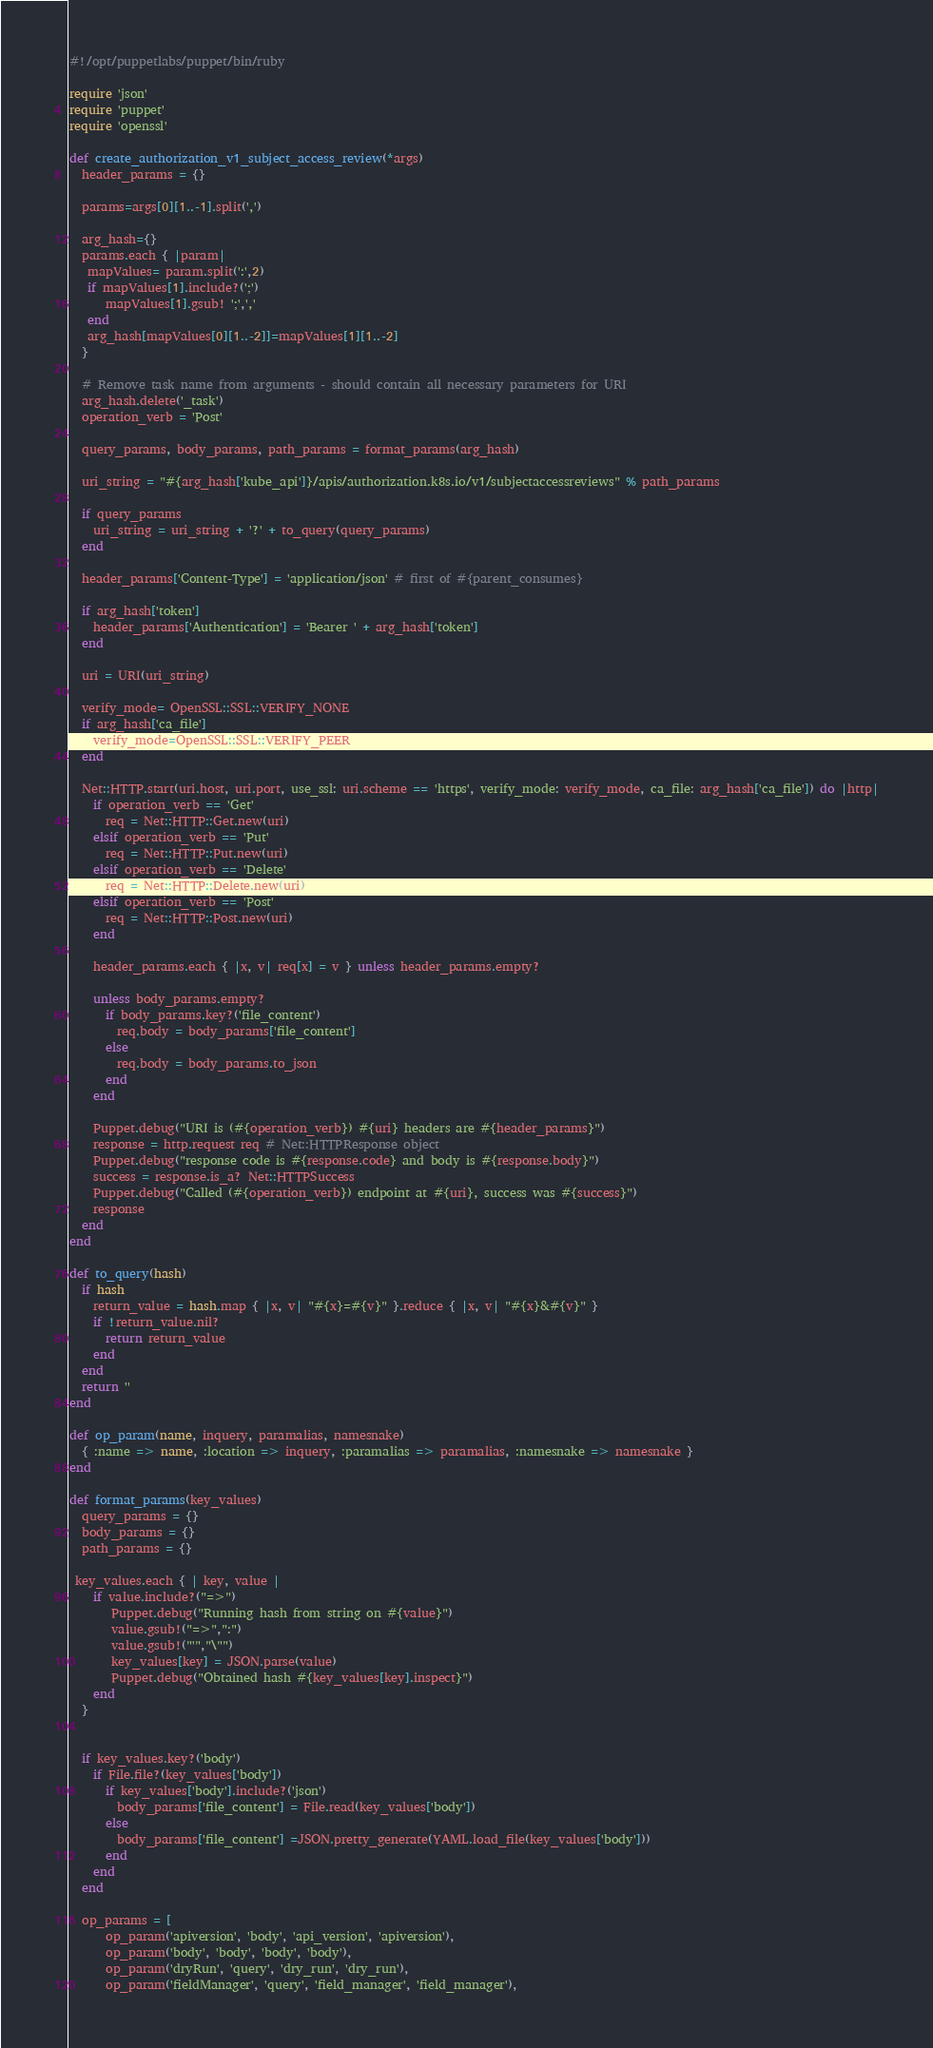Convert code to text. <code><loc_0><loc_0><loc_500><loc_500><_Ruby_>#!/opt/puppetlabs/puppet/bin/ruby

require 'json'
require 'puppet'
require 'openssl'

def create_authorization_v1_subject_access_review(*args)
  header_params = {}
  
  params=args[0][1..-1].split(',')

  arg_hash={}
  params.each { |param|
   mapValues= param.split(':',2)
   if mapValues[1].include?(';')
      mapValues[1].gsub! ';',','
   end
   arg_hash[mapValues[0][1..-2]]=mapValues[1][1..-2]
  }

  # Remove task name from arguments - should contain all necessary parameters for URI
  arg_hash.delete('_task')
  operation_verb = 'Post'

  query_params, body_params, path_params = format_params(arg_hash)

  uri_string = "#{arg_hash['kube_api']}/apis/authorization.k8s.io/v1/subjectaccessreviews" % path_params

  if query_params
    uri_string = uri_string + '?' + to_query(query_params)
  end

  header_params['Content-Type'] = 'application/json' # first of #{parent_consumes}

  if arg_hash['token']
    header_params['Authentication'] = 'Bearer ' + arg_hash['token']
  end

  uri = URI(uri_string)
 
  verify_mode= OpenSSL::SSL::VERIFY_NONE
  if arg_hash['ca_file']
    verify_mode=OpenSSL::SSL::VERIFY_PEER
  end

  Net::HTTP.start(uri.host, uri.port, use_ssl: uri.scheme == 'https', verify_mode: verify_mode, ca_file: arg_hash['ca_file']) do |http|
    if operation_verb == 'Get'
      req = Net::HTTP::Get.new(uri)
    elsif operation_verb == 'Put'
      req = Net::HTTP::Put.new(uri)
    elsif operation_verb == 'Delete'
      req = Net::HTTP::Delete.new(uri)
    elsif operation_verb == 'Post'
      req = Net::HTTP::Post.new(uri)
    end

    header_params.each { |x, v| req[x] = v } unless header_params.empty?

    unless body_params.empty?
      if body_params.key?('file_content')
        req.body = body_params['file_content']
      else
        req.body = body_params.to_json
      end
    end

    Puppet.debug("URI is (#{operation_verb}) #{uri} headers are #{header_params}")
    response = http.request req # Net::HTTPResponse object
    Puppet.debug("response code is #{response.code} and body is #{response.body}")
    success = response.is_a? Net::HTTPSuccess
    Puppet.debug("Called (#{operation_verb}) endpoint at #{uri}, success was #{success}")
    response
  end
end

def to_query(hash)
  if hash
    return_value = hash.map { |x, v| "#{x}=#{v}" }.reduce { |x, v| "#{x}&#{v}" }
    if !return_value.nil?
      return return_value
    end
  end
  return ''
end

def op_param(name, inquery, paramalias, namesnake)
  { :name => name, :location => inquery, :paramalias => paramalias, :namesnake => namesnake }
end

def format_params(key_values)
  query_params = {}
  body_params = {}
  path_params = {}

 key_values.each { | key, value |
    if value.include?("=>")
       Puppet.debug("Running hash from string on #{value}")
       value.gsub!("=>",":")
       value.gsub!("'","\"")
       key_values[key] = JSON.parse(value)
       Puppet.debug("Obtained hash #{key_values[key].inspect}")
    end
  }


  if key_values.key?('body')
    if File.file?(key_values['body'])
      if key_values['body'].include?('json')
        body_params['file_content'] = File.read(key_values['body'])
      else
        body_params['file_content'] =JSON.pretty_generate(YAML.load_file(key_values['body']))
      end
    end
  end

  op_params = [
      op_param('apiversion', 'body', 'api_version', 'apiversion'),
      op_param('body', 'body', 'body', 'body'),
      op_param('dryRun', 'query', 'dry_run', 'dry_run'),
      op_param('fieldManager', 'query', 'field_manager', 'field_manager'),</code> 